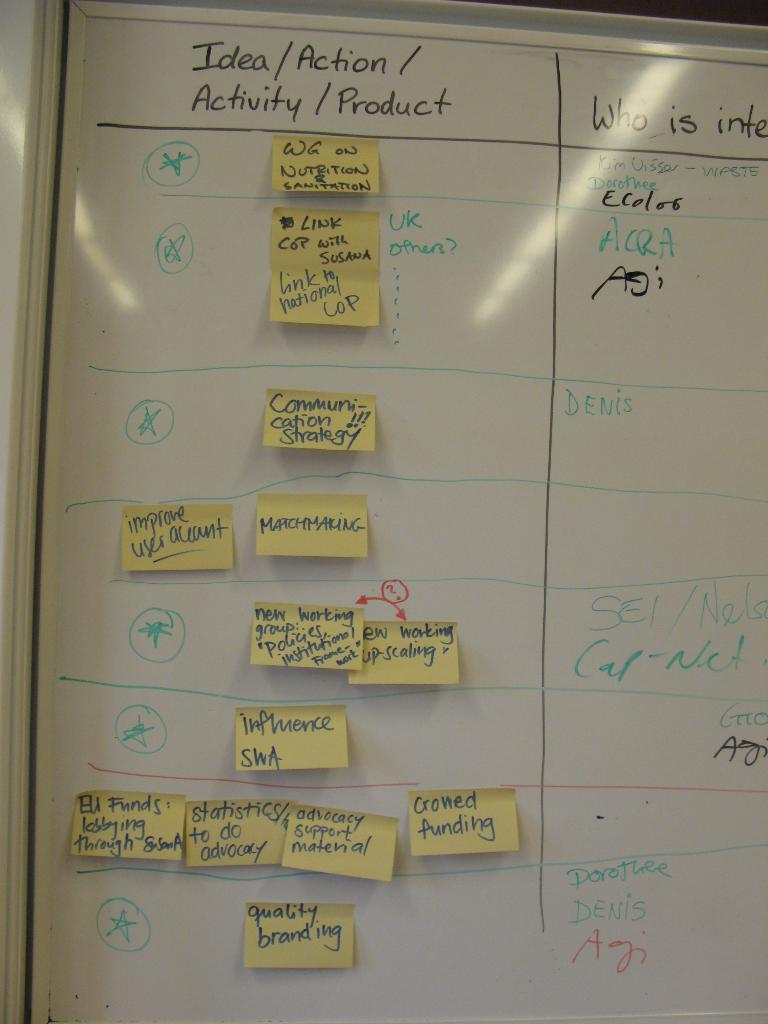<image>
Write a terse but informative summary of the picture. A white board with the topic Idea/Action written on the top. 